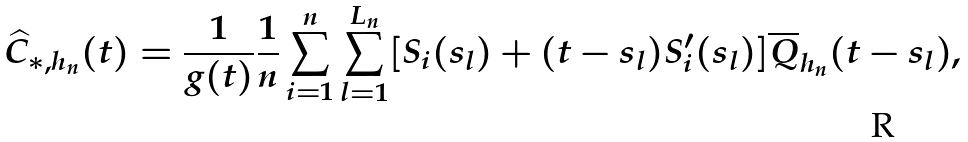<formula> <loc_0><loc_0><loc_500><loc_500>\widehat { C } _ { * , h _ { n } } ( t ) = \frac { 1 } { g ( t ) } \frac { 1 } { n } \sum _ { i = 1 } ^ { n } \sum _ { l = 1 } ^ { L _ { n } } [ S _ { i } ( s _ { l } ) + ( t - s _ { l } ) S _ { i } ^ { \prime } ( s _ { l } ) ] \overline { Q } _ { h _ { n } } ( t - s _ { l } ) ,</formula> 